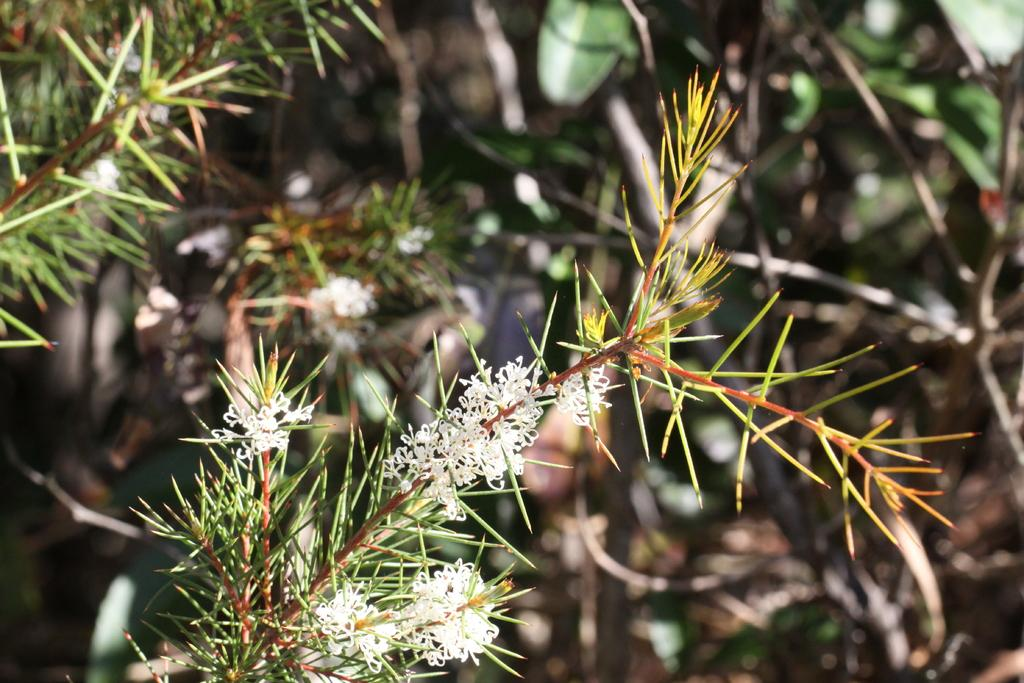What color are the flowers in the image? The flowers in the image are white. What are the flowers attached to? The flowers are on plants. Can you describe the plants in the background of the image? The plants in the background are blurry. How many ladybugs can be seen on the bed in the image? There is no bed or ladybugs present in the image. 